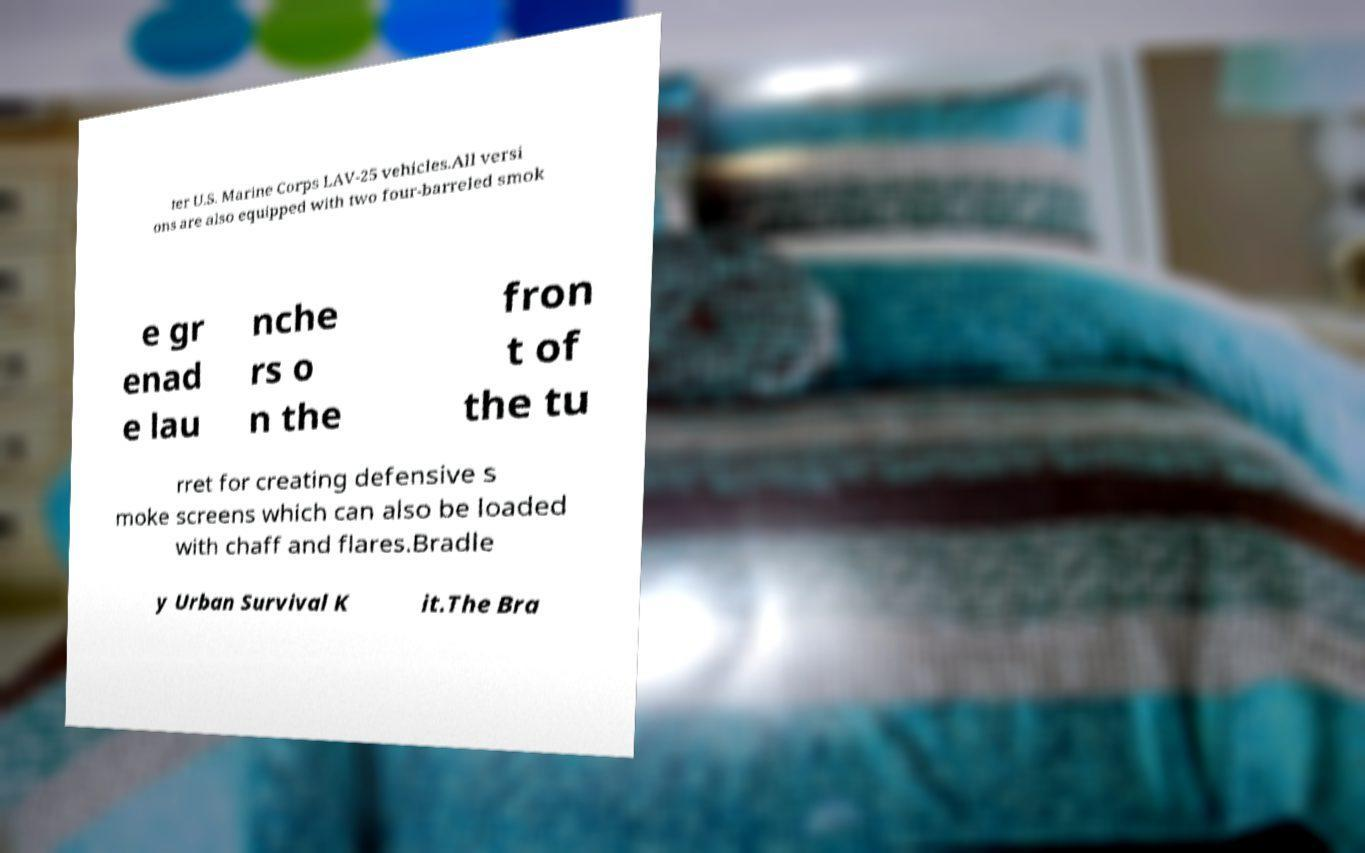Could you extract and type out the text from this image? ter U.S. Marine Corps LAV-25 vehicles.All versi ons are also equipped with two four-barreled smok e gr enad e lau nche rs o n the fron t of the tu rret for creating defensive s moke screens which can also be loaded with chaff and flares.Bradle y Urban Survival K it.The Bra 